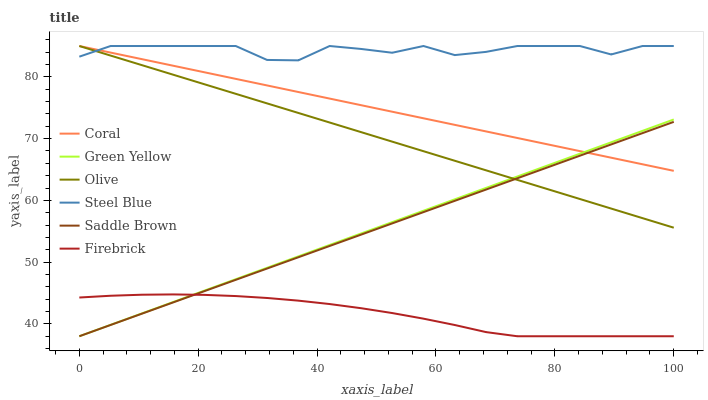Does Saddle Brown have the minimum area under the curve?
Answer yes or no. No. Does Saddle Brown have the maximum area under the curve?
Answer yes or no. No. Is Saddle Brown the smoothest?
Answer yes or no. No. Is Saddle Brown the roughest?
Answer yes or no. No. Does Steel Blue have the lowest value?
Answer yes or no. No. Does Saddle Brown have the highest value?
Answer yes or no. No. Is Saddle Brown less than Steel Blue?
Answer yes or no. Yes. Is Coral greater than Firebrick?
Answer yes or no. Yes. Does Saddle Brown intersect Steel Blue?
Answer yes or no. No. 